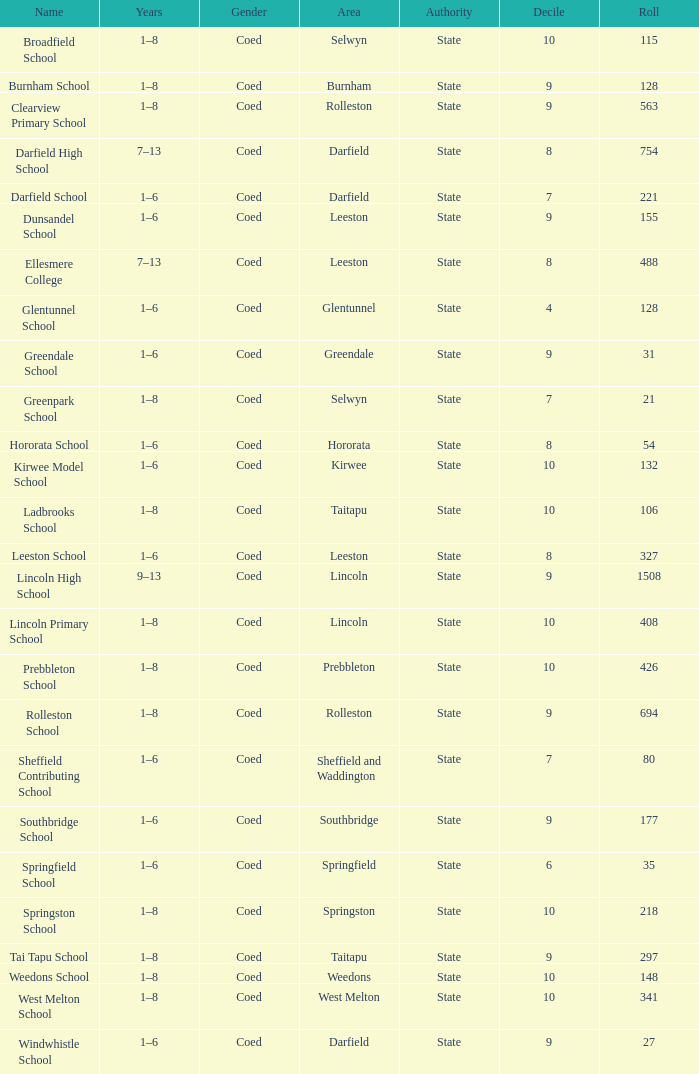Which years have a Name of ladbrooks school? 1–8. 